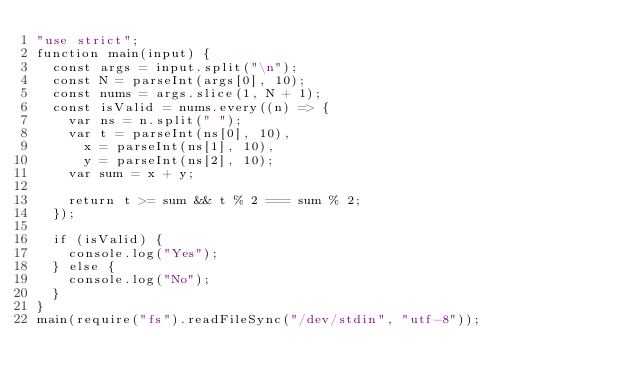Convert code to text. <code><loc_0><loc_0><loc_500><loc_500><_JavaScript_>"use strict";
function main(input) {
  const args = input.split("\n");
  const N = parseInt(args[0], 10);
  const nums = args.slice(1, N + 1);
  const isValid = nums.every((n) => {
    var ns = n.split(" ");
    var t = parseInt(ns[0], 10),
      x = parseInt(ns[1], 10),
      y = parseInt(ns[2], 10);
    var sum = x + y;

    return t >= sum && t % 2 === sum % 2;
  });

  if (isValid) {
    console.log("Yes");
  } else {
    console.log("No");
  }
}
main(require("fs").readFileSync("/dev/stdin", "utf-8"));
</code> 